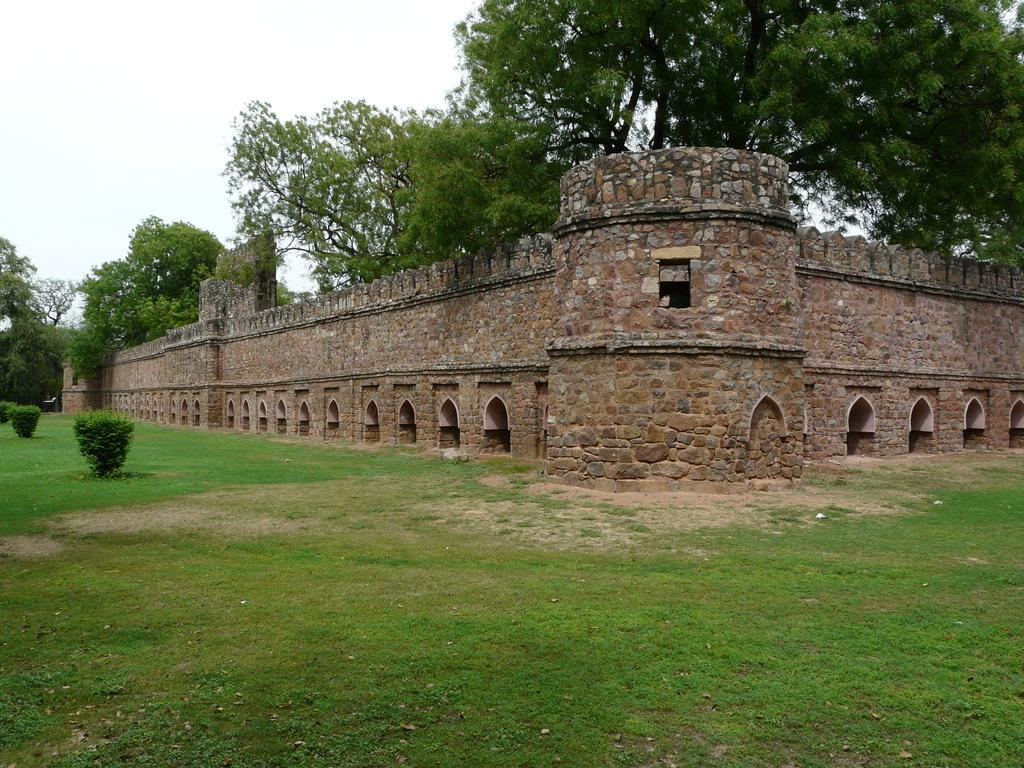What type of vegetation can be seen in the image? There is grass and plants in the image. What structures are present in the image? There is a wall in the image. What other natural elements can be seen in the image? There are trees in the image. What is visible in the background of the image? The sky is visible in the background of the image. What type of apparatus can be seen hanging from the trees in the image? There is no apparatus hanging from the trees in the image; it only features grass, plants, a wall, trees, and the sky. Can you see any cobwebs in the image? There is no mention of cobwebs in the image, and they are not visible in the provided facts. 